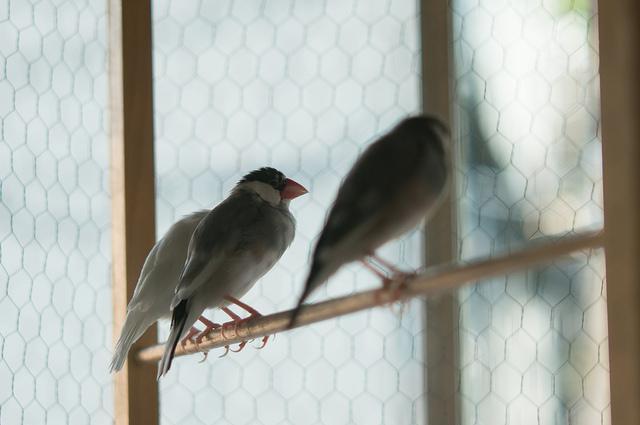How many birds are there?
Give a very brief answer. 3. How many birds are in the picture?
Give a very brief answer. 3. 